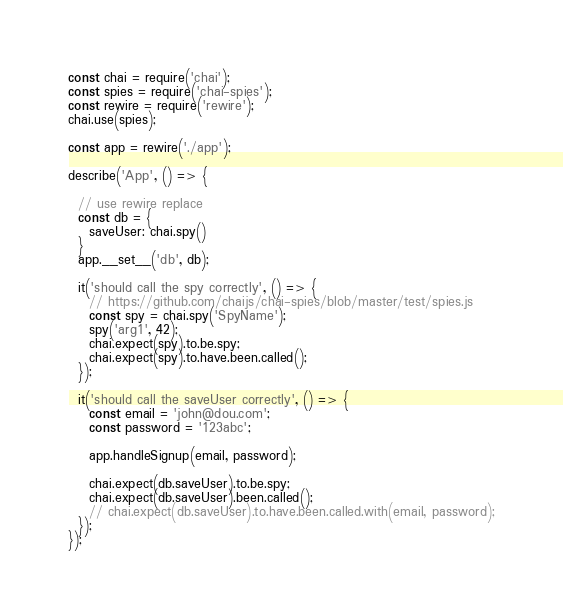<code> <loc_0><loc_0><loc_500><loc_500><_JavaScript_>const chai = require('chai');
const spies = require('chai-spies');
const rewire = require('rewire');
chai.use(spies);

const app = rewire('./app');

describe('App', () => {

  // use rewire replace
  const db = {
    saveUser: chai.spy()
  }
  app.__set__('db', db);

  it('should call the spy correctly', () => {
    // https://github.com/chaijs/chai-spies/blob/master/test/spies.js
    const spy = chai.spy('SpyName');
    spy('arg1', 42);
    chai.expect(spy).to.be.spy;
    chai.expect(spy).to.have.been.called();
  });

  it('should call the saveUser correctly', () => {
    const email = 'john@dou.com';
    const password = '123abc';

    app.handleSignup(email, password);

    chai.expect(db.saveUser).to.be.spy;
    chai.expect(db.saveUser).been.called();
    // chai.expect(db.saveUser).to.have.been.called.with(email, password);
  });
});
</code> 